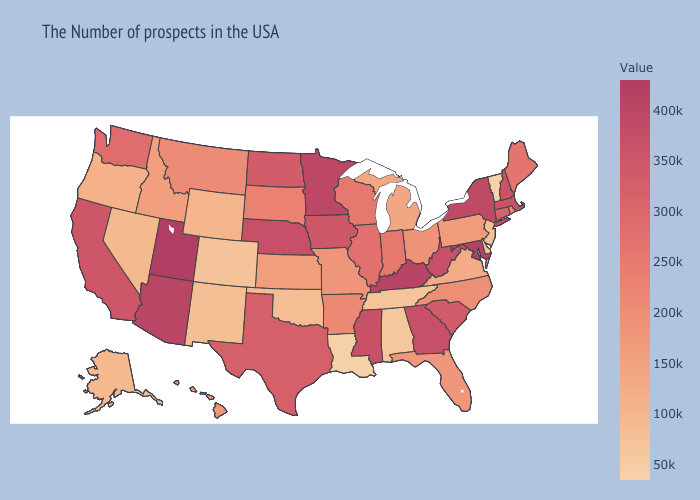Does the map have missing data?
Short answer required. No. Does Kansas have a higher value than Mississippi?
Concise answer only. No. Does New Hampshire have the highest value in the USA?
Give a very brief answer. No. Which states have the lowest value in the West?
Answer briefly. Colorado. Does California have a higher value than Rhode Island?
Concise answer only. Yes. Which states have the highest value in the USA?
Answer briefly. Utah. Among the states that border Indiana , does Michigan have the lowest value?
Concise answer only. Yes. Does Illinois have a lower value than Georgia?
Write a very short answer. Yes. 